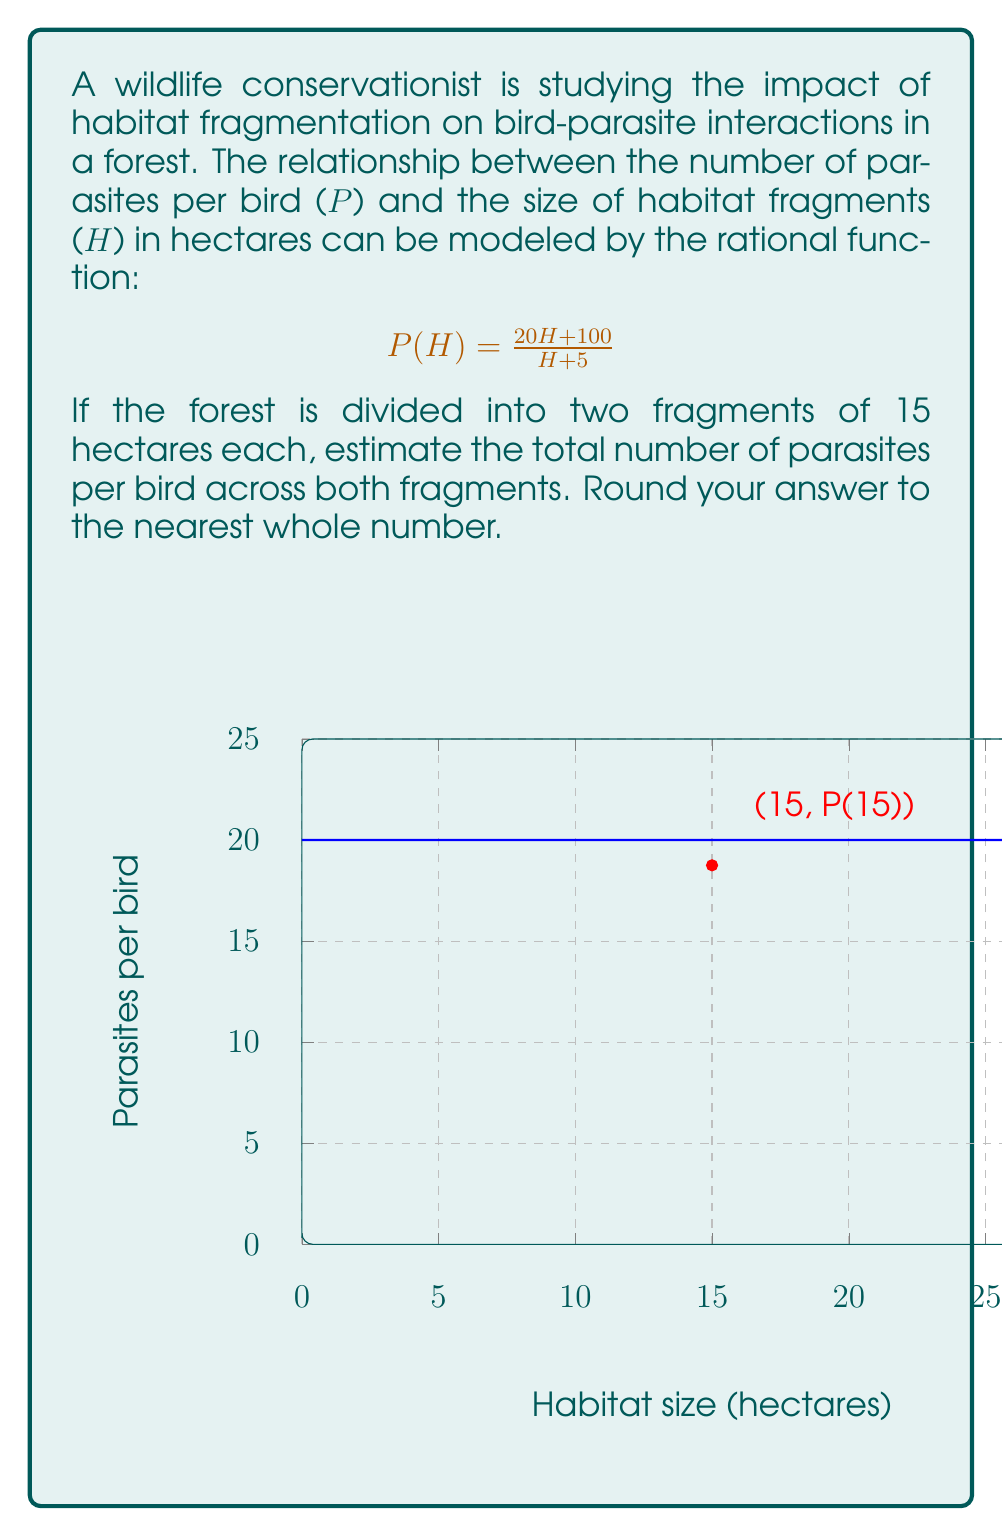Solve this math problem. Let's approach this step-by-step:

1) We need to calculate P(15) since each fragment is 15 hectares.

2) Substitute H = 15 into the given function:

   $$P(15) = \frac{20(15) + 100}{15 + 5}$$

3) Simplify:
   
   $$P(15) = \frac{300 + 100}{20} = \frac{400}{20}$$

4) Calculate:
   
   $$P(15) = 20$$

5) This means there are 20 parasites per bird in each 15-hectare fragment.

6) Since there are two fragments, we multiply this by 2:

   $$\text{Total parasites} = 20 \times 2 = 40$$

7) The question asks to round to the nearest whole number, but 40 is already a whole number.

Therefore, the estimated total number of parasites per bird across both fragments is 40.
Answer: 40 parasites per bird 